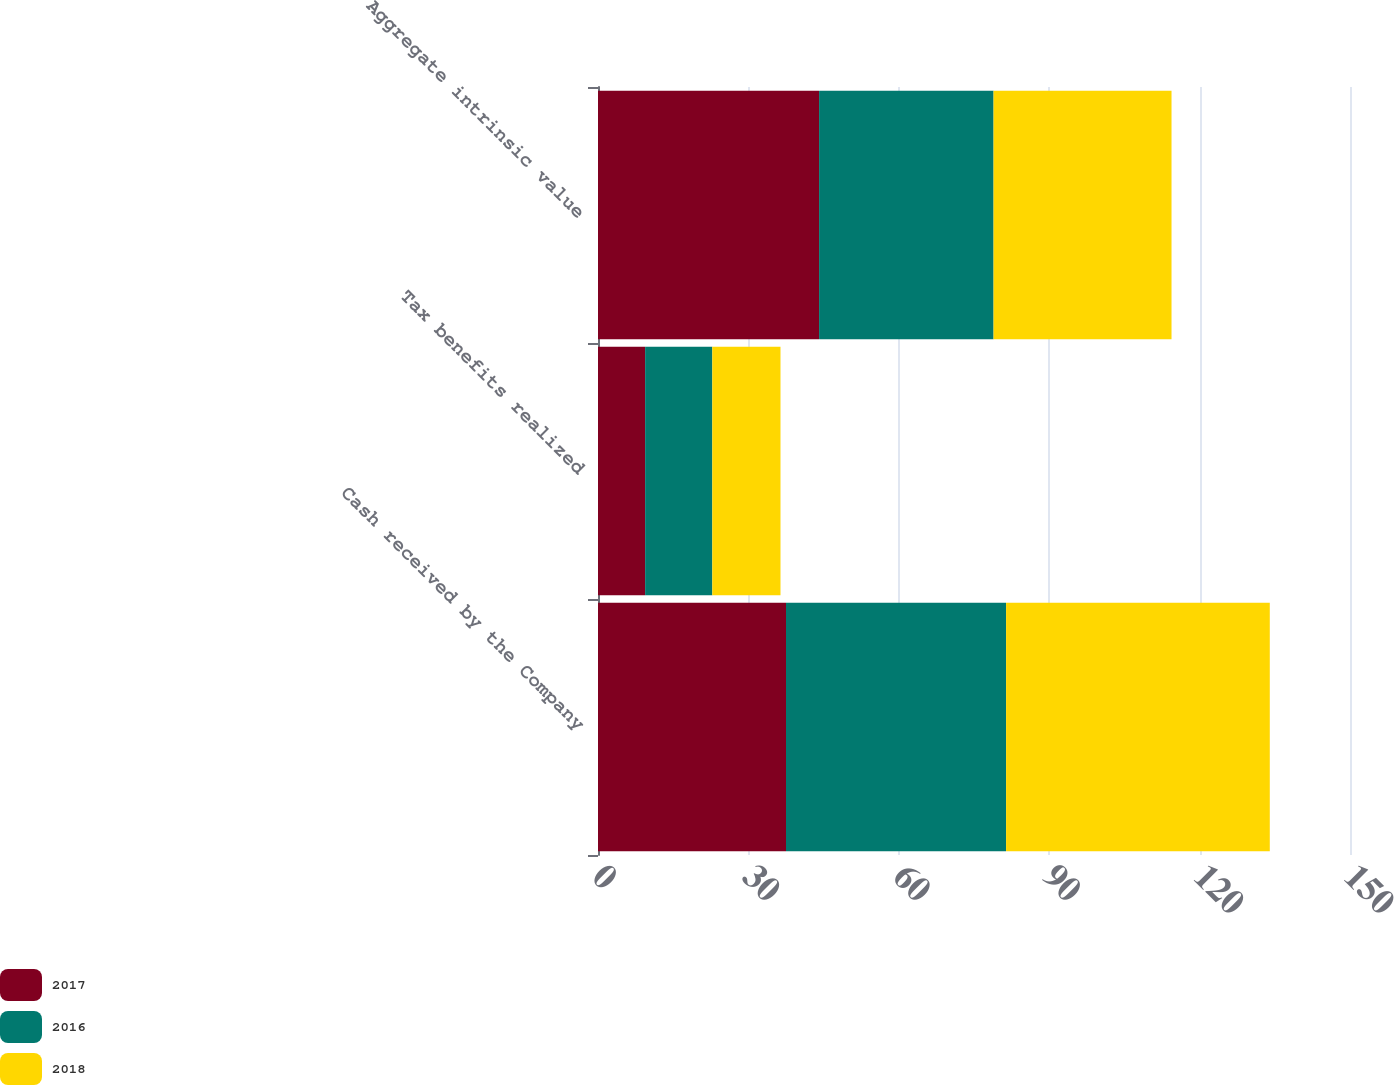Convert chart. <chart><loc_0><loc_0><loc_500><loc_500><stacked_bar_chart><ecel><fcel>Cash received by the Company<fcel>Tax benefits realized<fcel>Aggregate intrinsic value<nl><fcel>2017<fcel>37.5<fcel>9.4<fcel>44.1<nl><fcel>2016<fcel>43.9<fcel>13.4<fcel>34.8<nl><fcel>2018<fcel>52.6<fcel>13.6<fcel>35.5<nl></chart> 